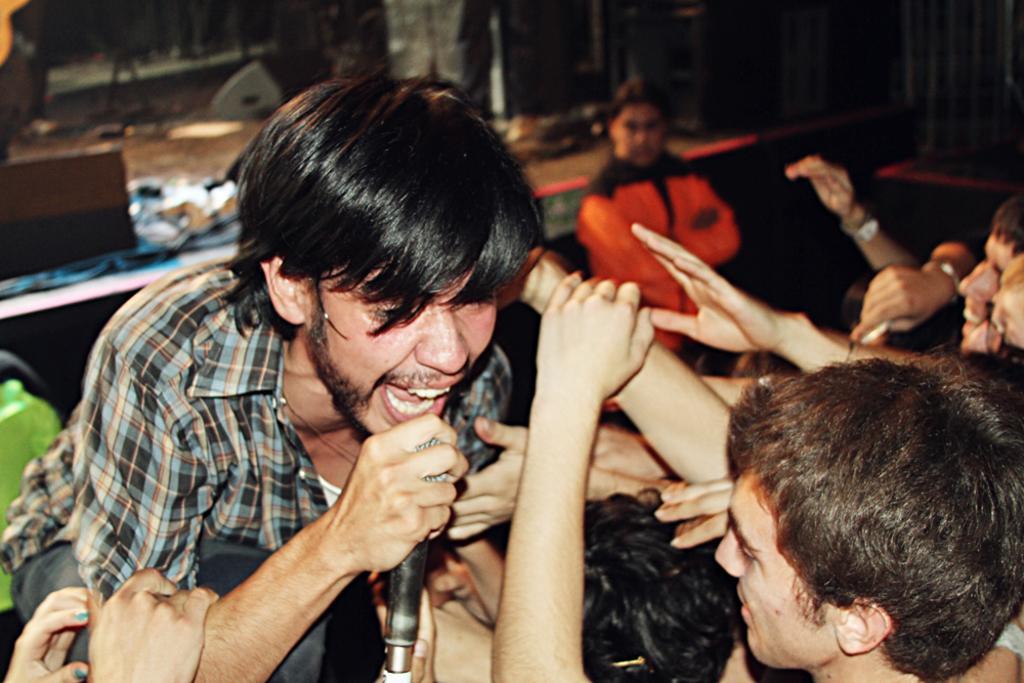How would you summarize this image in a sentence or two? In this image I can see number of people and on the left side I can see one of them is holding a mic. In the background I can see the stage and on it I can see number of stuffs. I can also see this image is little bit blurry in the background. 